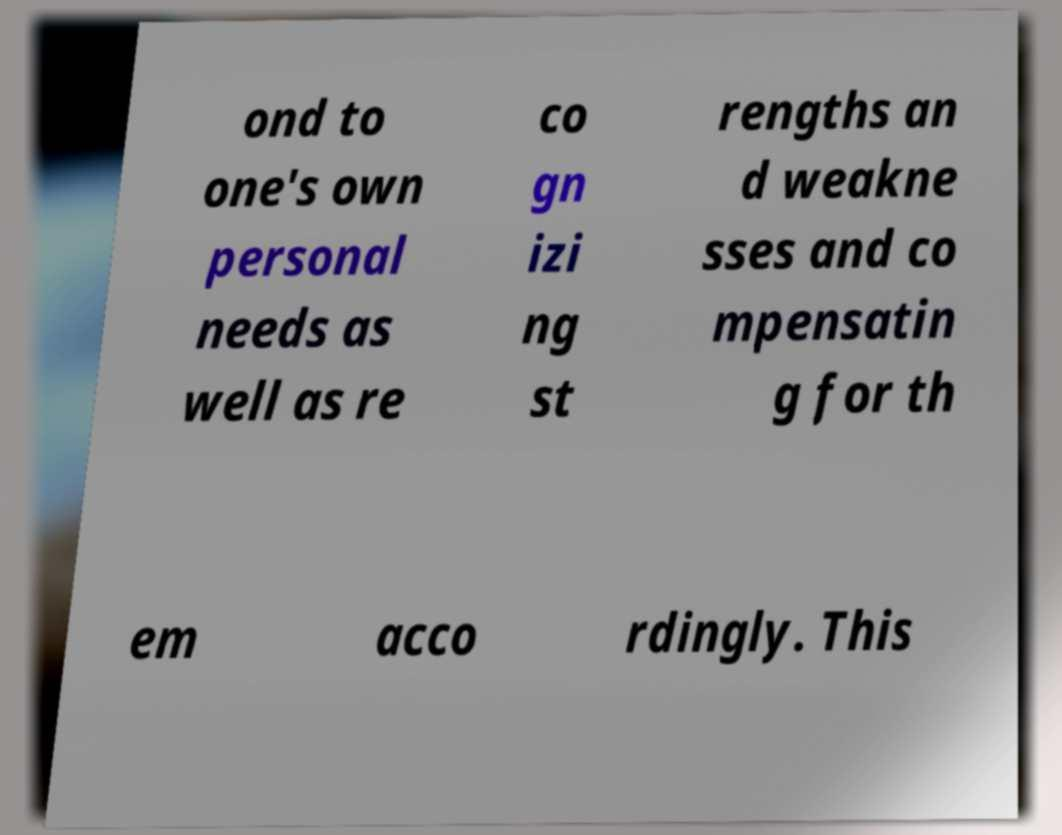Can you accurately transcribe the text from the provided image for me? ond to one's own personal needs as well as re co gn izi ng st rengths an d weakne sses and co mpensatin g for th em acco rdingly. This 